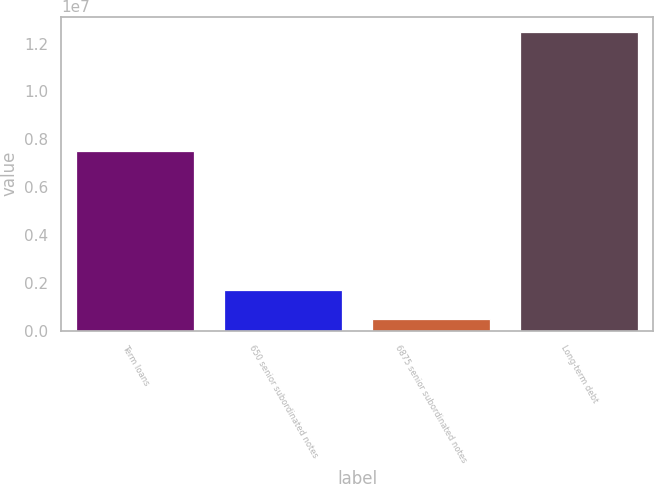<chart> <loc_0><loc_0><loc_500><loc_500><bar_chart><fcel>Term loans<fcel>650 senior subordinated notes<fcel>6875 senior subordinated notes<fcel>Long-term debt<nl><fcel>7.5092e+06<fcel>1.6919e+06<fcel>490779<fcel>1.25019e+07<nl></chart> 